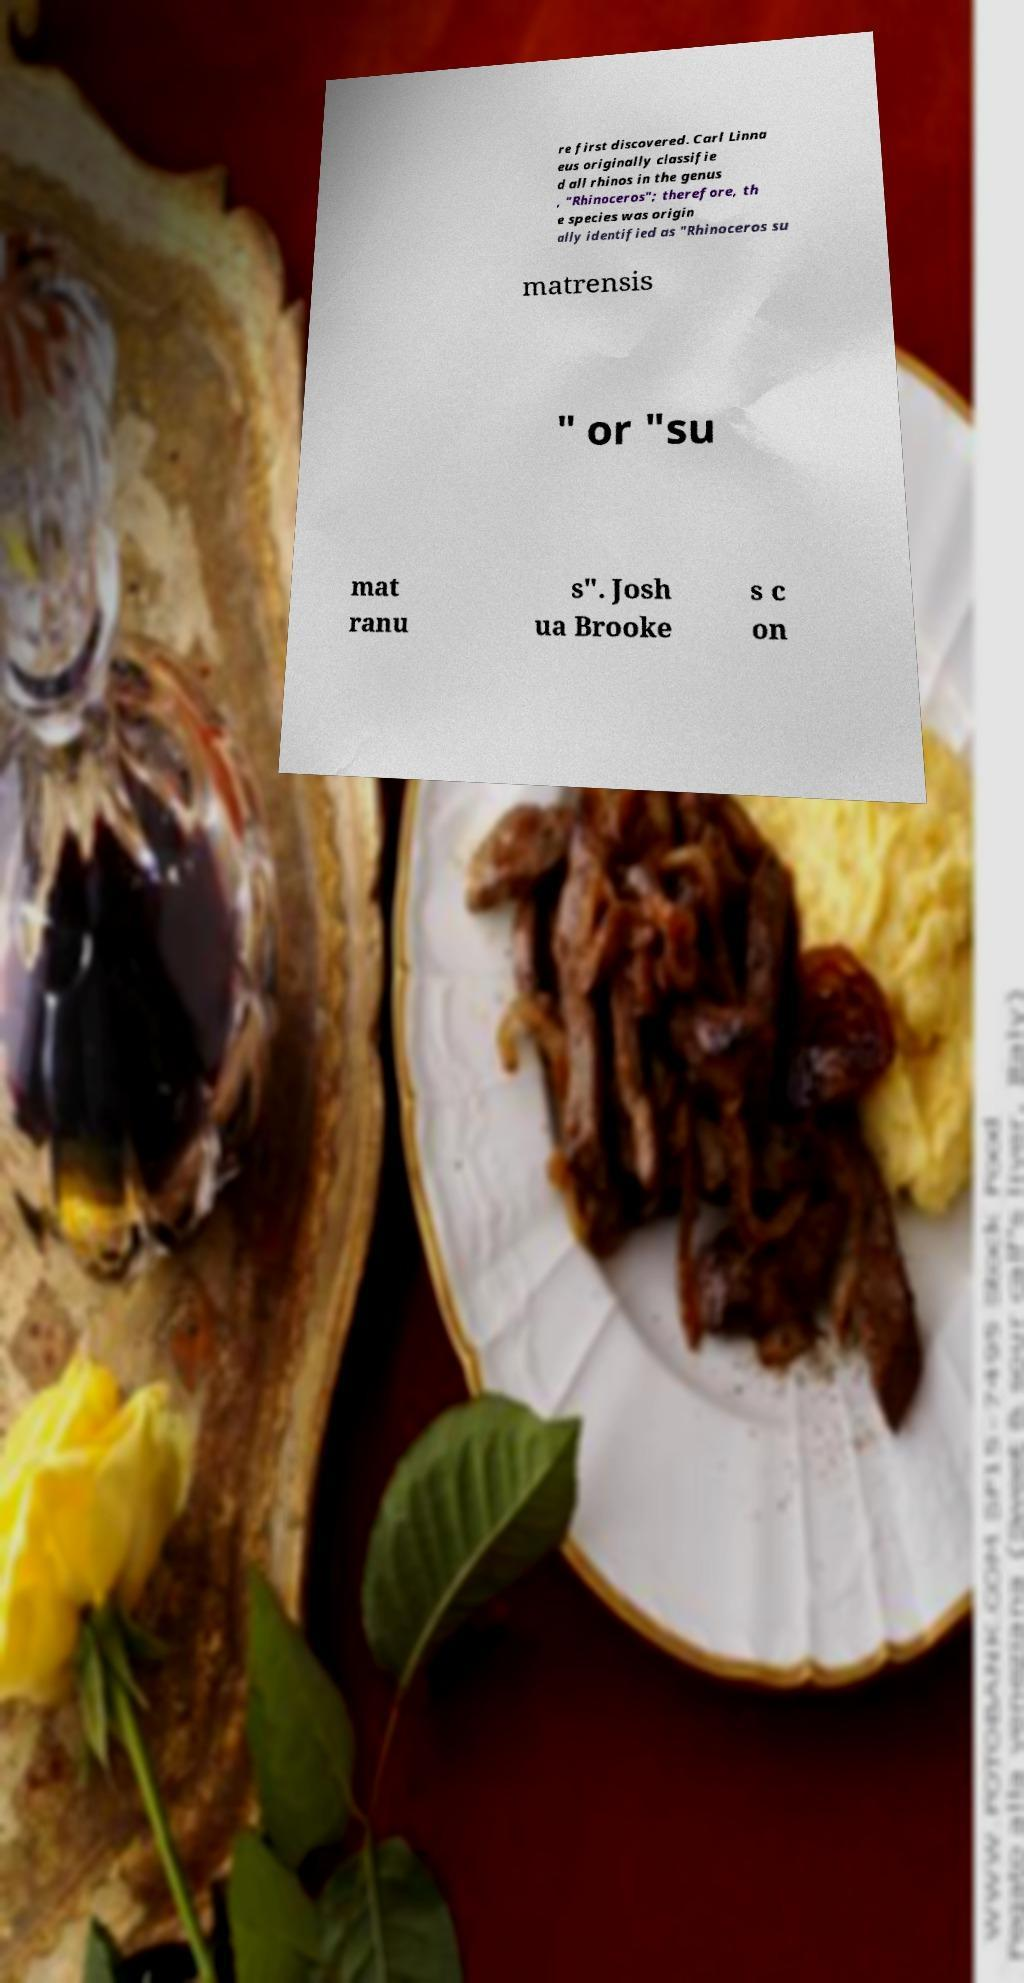Can you read and provide the text displayed in the image?This photo seems to have some interesting text. Can you extract and type it out for me? re first discovered. Carl Linna eus originally classifie d all rhinos in the genus , "Rhinoceros"; therefore, th e species was origin ally identified as "Rhinoceros su matrensis " or "su mat ranu s". Josh ua Brooke s c on 